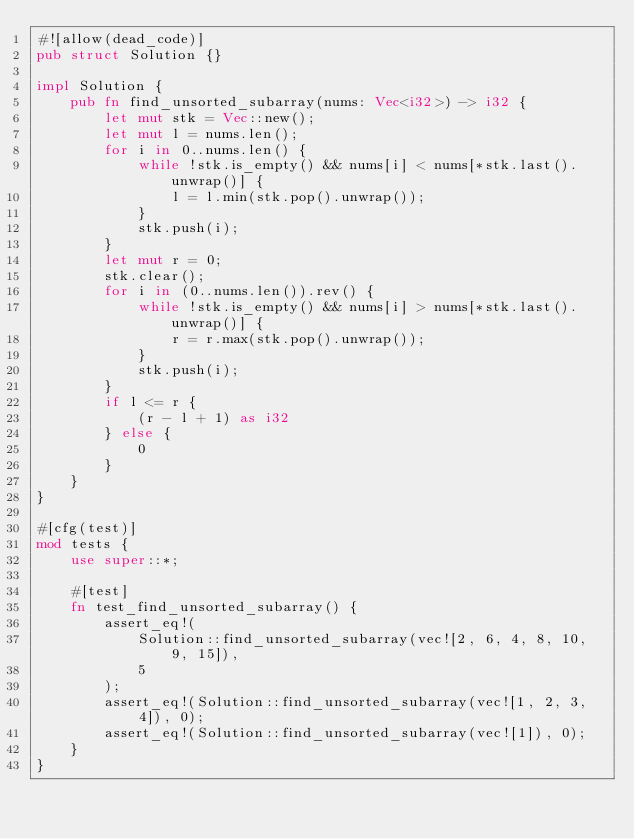Convert code to text. <code><loc_0><loc_0><loc_500><loc_500><_Rust_>#![allow(dead_code)]
pub struct Solution {}

impl Solution {
    pub fn find_unsorted_subarray(nums: Vec<i32>) -> i32 {
        let mut stk = Vec::new();
        let mut l = nums.len();
        for i in 0..nums.len() {
            while !stk.is_empty() && nums[i] < nums[*stk.last().unwrap()] {
                l = l.min(stk.pop().unwrap());
            }
            stk.push(i);
        }
        let mut r = 0;
        stk.clear();
        for i in (0..nums.len()).rev() {
            while !stk.is_empty() && nums[i] > nums[*stk.last().unwrap()] {
                r = r.max(stk.pop().unwrap());
            }
            stk.push(i);
        }
        if l <= r {
            (r - l + 1) as i32
        } else {
            0
        }
    }
}

#[cfg(test)]
mod tests {
    use super::*;

    #[test]
    fn test_find_unsorted_subarray() {
        assert_eq!(
            Solution::find_unsorted_subarray(vec![2, 6, 4, 8, 10, 9, 15]),
            5
        );
        assert_eq!(Solution::find_unsorted_subarray(vec![1, 2, 3, 4]), 0);
        assert_eq!(Solution::find_unsorted_subarray(vec![1]), 0);
    }
}
</code> 